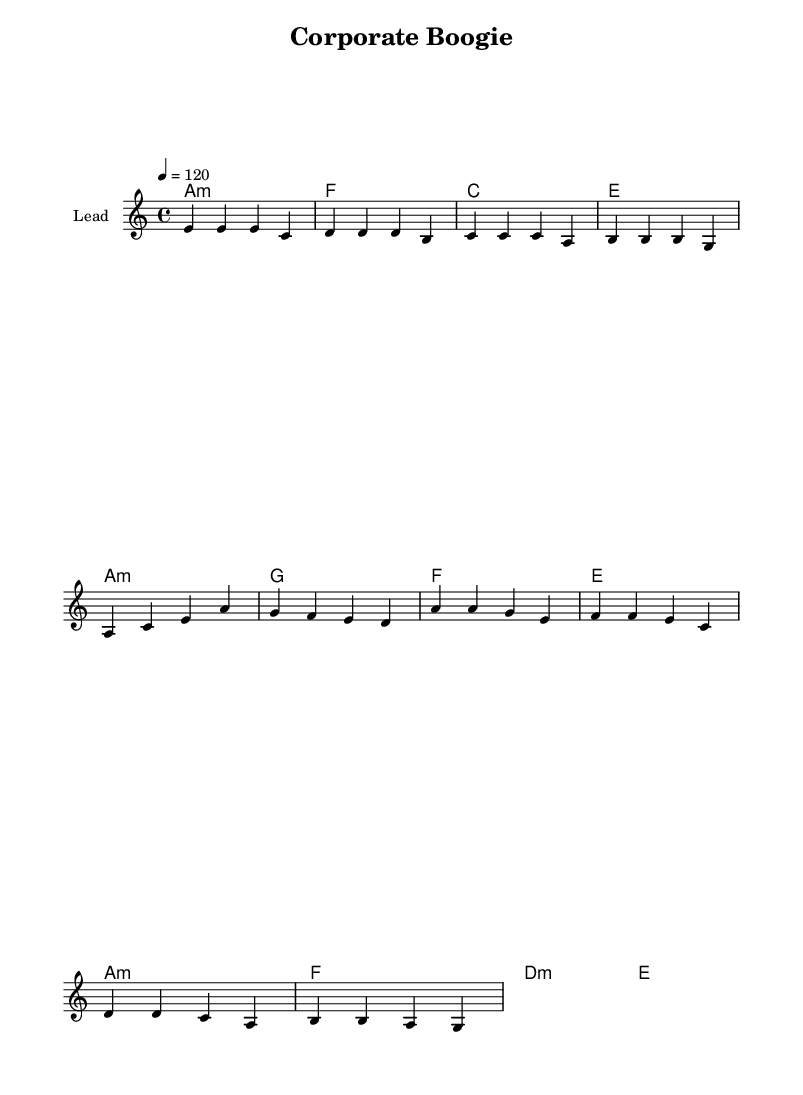What is the key signature of this music? The key signature is A minor, which contains no sharps or flats, indicated by the absence of any accidentals in the staff.
Answer: A minor What is the time signature of this music? The time signature is 4/4, which means there are four beats in each measure. This is indicated at the beginning of the sheet music and is a common time signature in disco music.
Answer: 4/4 What is the tempo marking in this music? The tempo marking is indicated to be 120 beats per minute, meaning a moderate disco beat, which is evident in the tempo indication at the beginning of the score.
Answer: 120 What is the name of the song? The title of the song is "Corporate Boogie," which is found in the header of the music sheet.
Answer: Corporate Boogie What chord is played on the first measure? The first measure has an A minor chord, which is represented in the chord names section and provides the harmonic foundation for the melody.
Answer: A minor How many measures are in the verse? The verse contains four measures as indicated by the grouping of notes and rests in the melody section. Each group represents a measure within the overall structure.
Answer: 4 What phrase in the lyrics suggests making tough decisions? The phrase "Tough decisions, we've got to make" from the lyrics section explicitly mentions the act of making difficult choices, which aligns with the theme of corporate challenges.
Answer: Tough decisions, we've got to make 